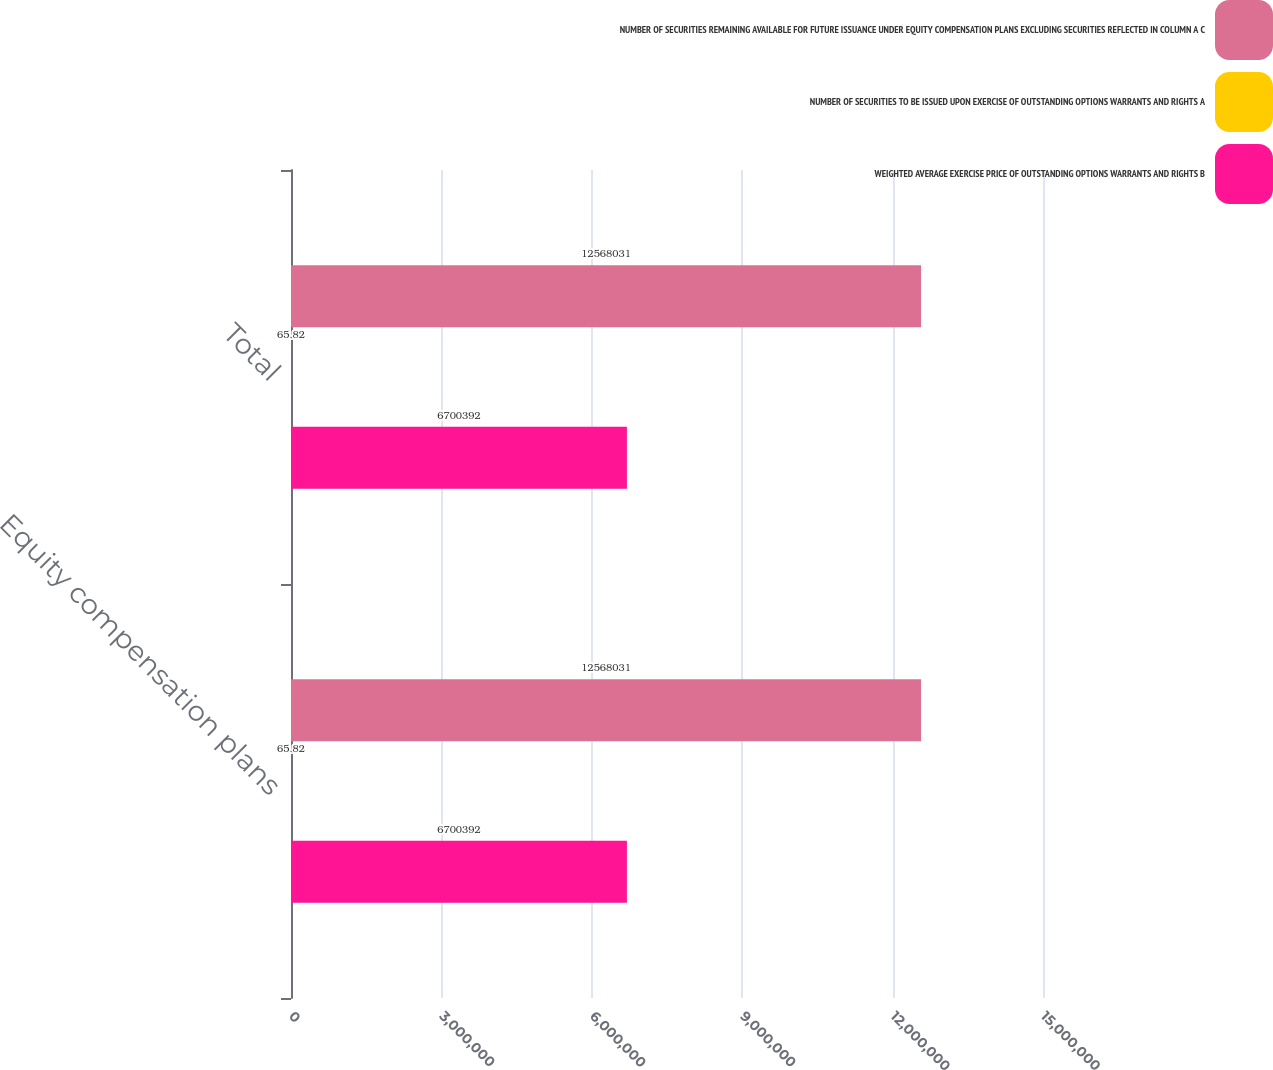<chart> <loc_0><loc_0><loc_500><loc_500><stacked_bar_chart><ecel><fcel>Equity compensation plans<fcel>Total<nl><fcel>NUMBER OF SECURITIES REMAINING AVAILABLE FOR FUTURE ISSUANCE UNDER EQUITY COMPENSATION PLANS EXCLUDING SECURITIES REFLECTED IN COLUMN A C<fcel>1.2568e+07<fcel>1.2568e+07<nl><fcel>NUMBER OF SECURITIES TO BE ISSUED UPON EXERCISE OF OUTSTANDING OPTIONS WARRANTS AND RIGHTS A<fcel>65.82<fcel>65.82<nl><fcel>WEIGHTED AVERAGE EXERCISE PRICE OF OUTSTANDING OPTIONS WARRANTS AND RIGHTS B<fcel>6.70039e+06<fcel>6.70039e+06<nl></chart> 